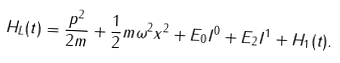Convert formula to latex. <formula><loc_0><loc_0><loc_500><loc_500>H _ { L } ( t ) = \frac { p ^ { 2 } } { 2 m } + \frac { 1 } { 2 } m \omega ^ { 2 } x ^ { 2 } + E _ { 0 } I ^ { 0 } + E _ { 2 } I ^ { 1 } + H _ { 1 } ( t ) .</formula> 